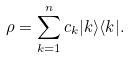Convert formula to latex. <formula><loc_0><loc_0><loc_500><loc_500>\rho = \sum _ { k = 1 } ^ { n } c _ { k } | k \rangle \langle k | .</formula> 